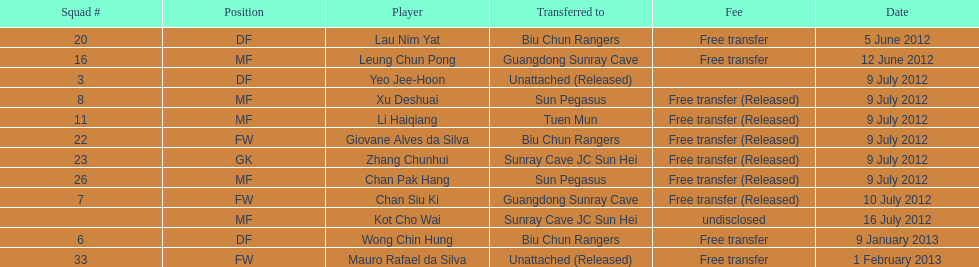For which team did lau nim yat perform after his relocation? Biu Chun Rangers. 